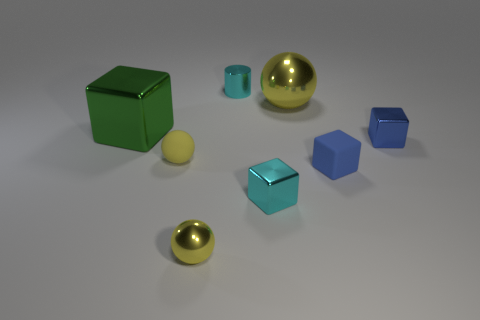Add 1 big green metal cylinders. How many objects exist? 9 Subtract all brown blocks. Subtract all green spheres. How many blocks are left? 4 Subtract 0 yellow cylinders. How many objects are left? 8 Subtract all cylinders. How many objects are left? 7 Subtract all matte blocks. Subtract all yellow balls. How many objects are left? 4 Add 5 big metal blocks. How many big metal blocks are left? 6 Add 3 big brown metal cubes. How many big brown metal cubes exist? 3 